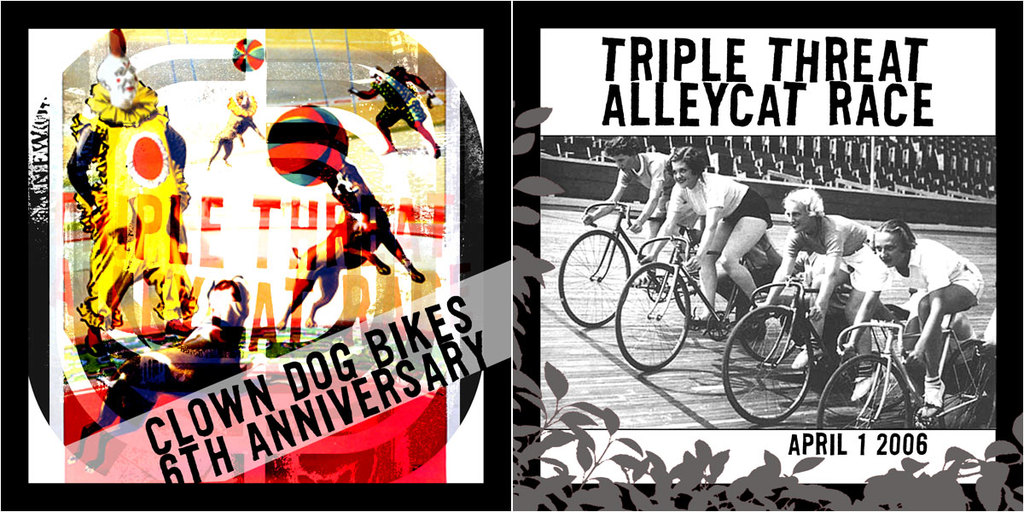What does the text 'Clown Dog Bikes' refer to in the context of this image? Clown Dog Bikes likely represents either a sponsor or the organizer behind the Triple Threat Alleycat Race, possibly a local bike shop known for supporting or initiating community-focused cycling events. 